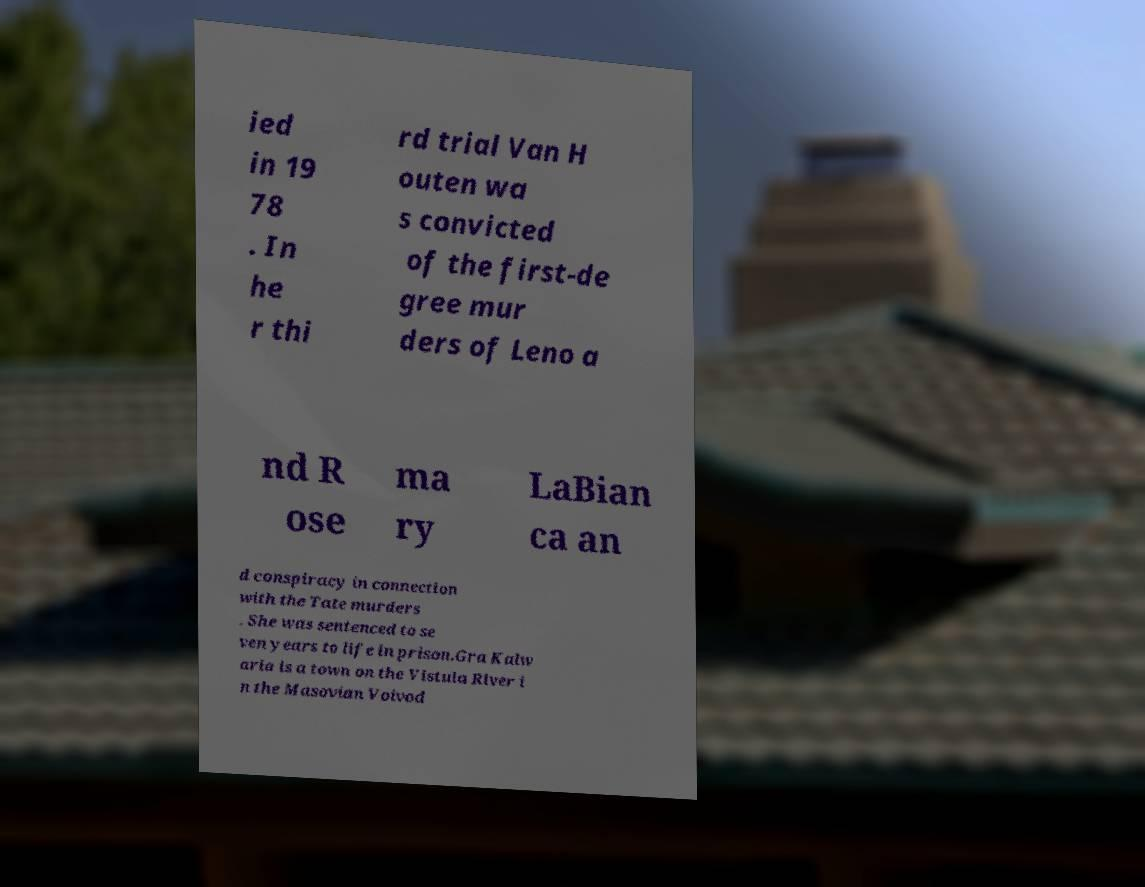Could you extract and type out the text from this image? ied in 19 78 . In he r thi rd trial Van H outen wa s convicted of the first-de gree mur ders of Leno a nd R ose ma ry LaBian ca an d conspiracy in connection with the Tate murders . She was sentenced to se ven years to life in prison.Gra Kalw aria is a town on the Vistula River i n the Masovian Voivod 